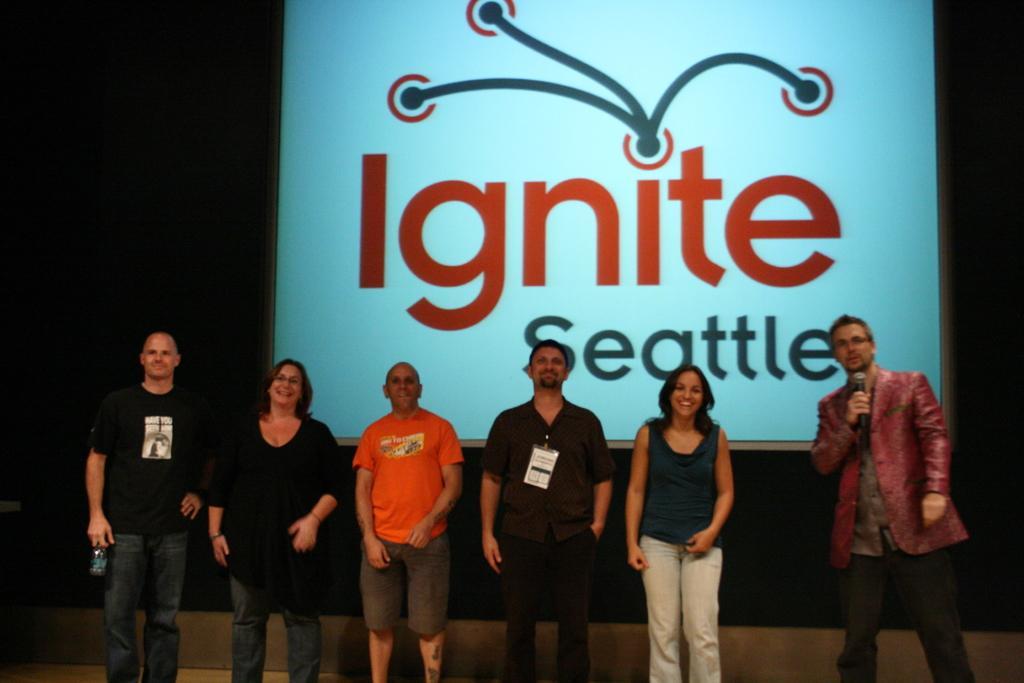How would you summarize this image in a sentence or two? There are some people standing. Person on the right is holding a mic. Person on the left is holding a bottle. And a person is wearing a tag. In the back there is a screen with something written. 